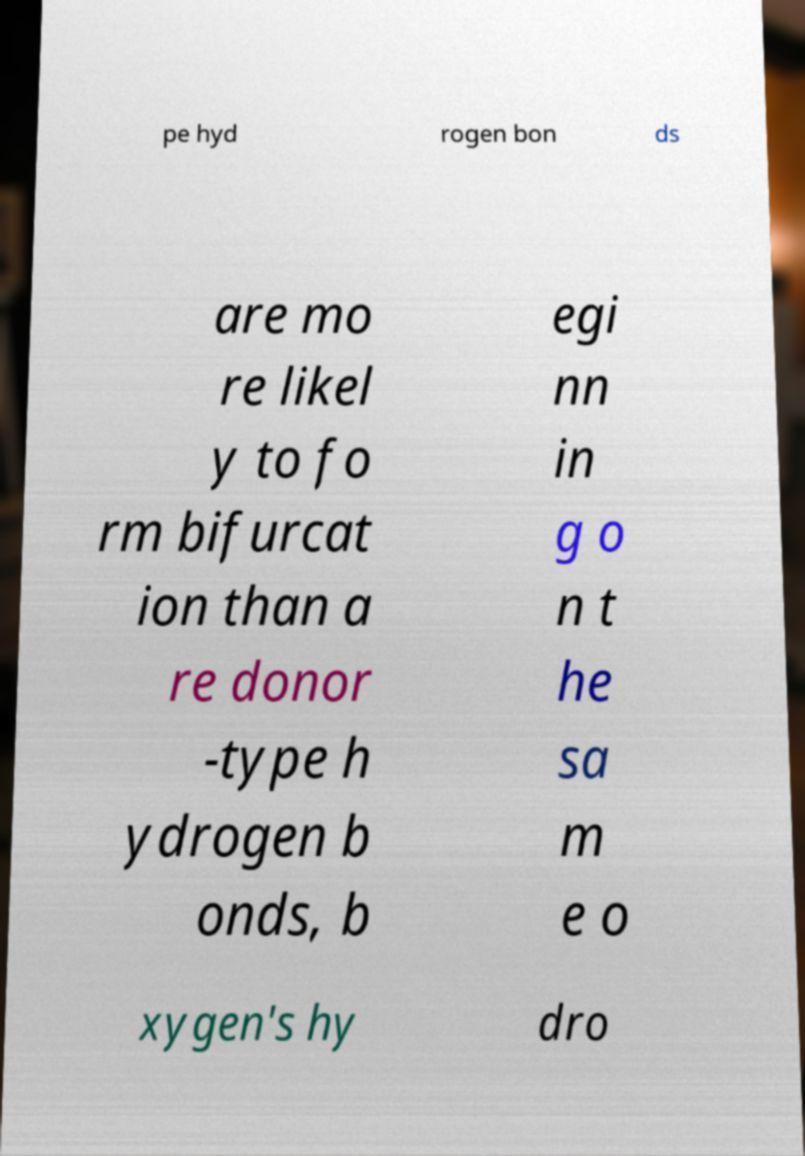I need the written content from this picture converted into text. Can you do that? pe hyd rogen bon ds are mo re likel y to fo rm bifurcat ion than a re donor -type h ydrogen b onds, b egi nn in g o n t he sa m e o xygen's hy dro 